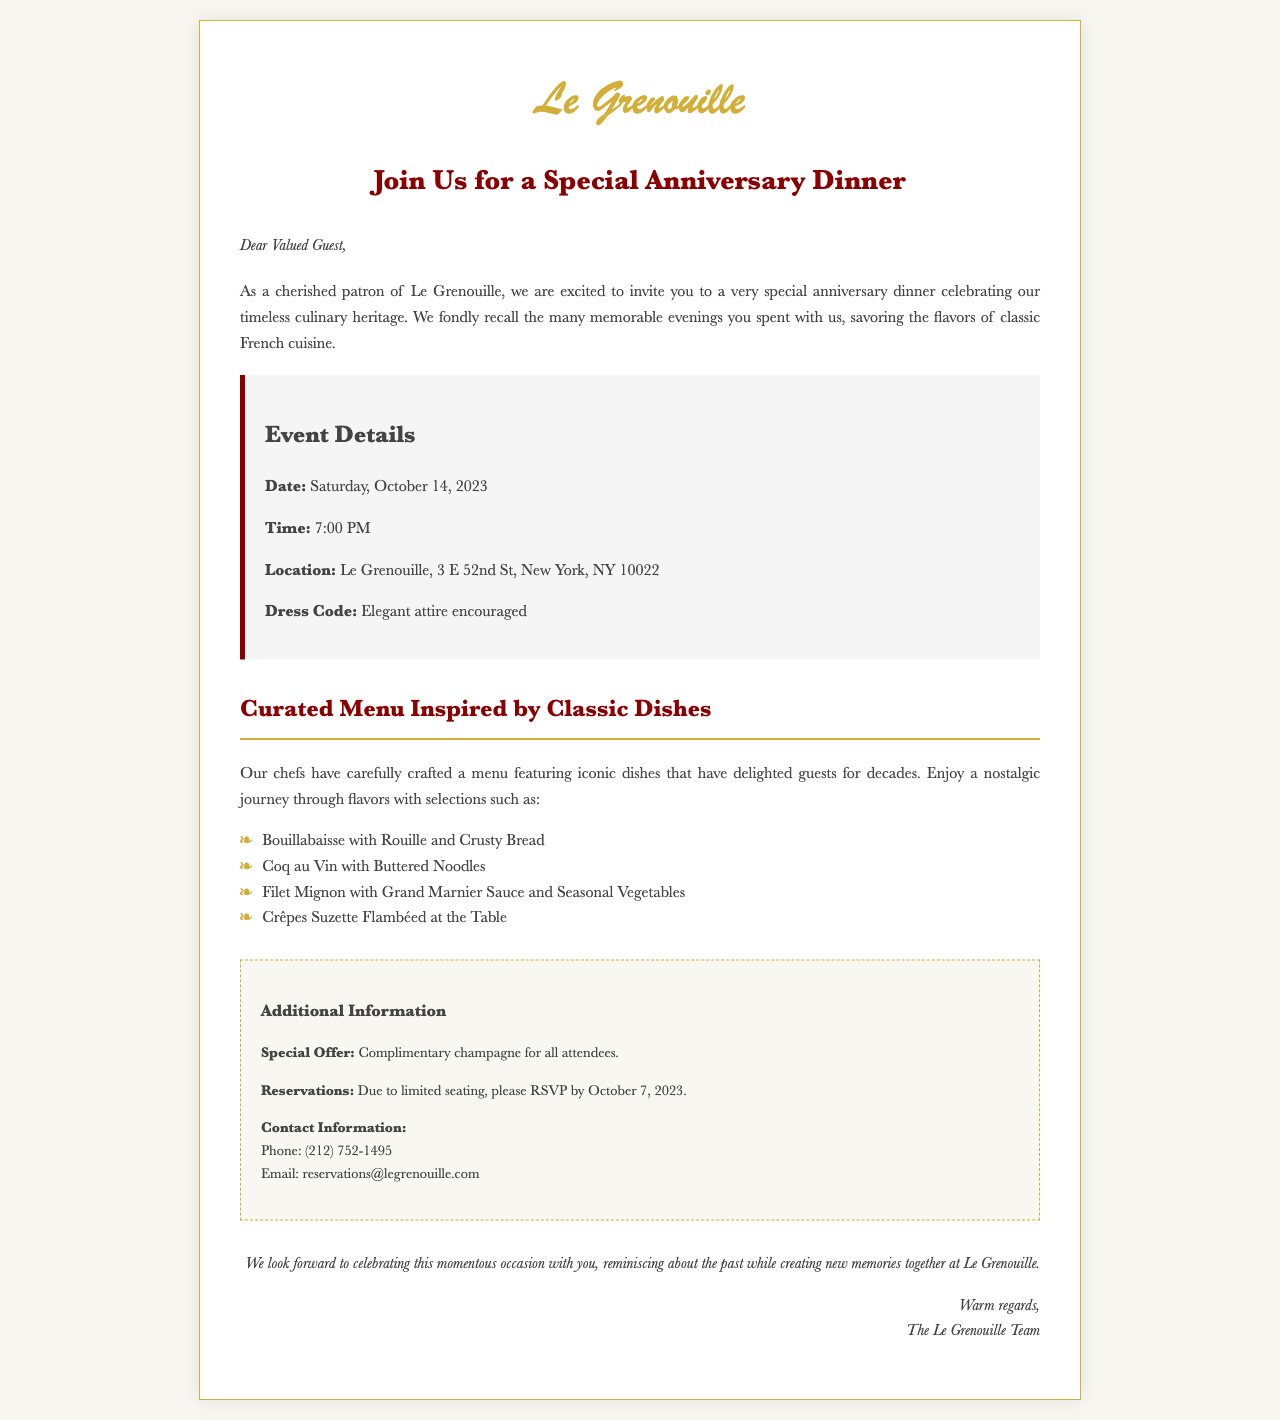what is the date of the event? The date of the anniversary dinner is stated in the event details section of the document.
Answer: Saturday, October 14, 2023 what time does the dinner start? The start time for the dinner is mentioned in the event details section.
Answer: 7:00 PM where is Le Grenouille located? The location of Le Grenouille is provided in the event details.
Answer: 3 E 52nd St, New York, NY 10022 what is the dress code for the event? The dress code is described in the event details of the invitation.
Answer: Elegant attire encouraged what is offered to all attendees? A special offer for the guests is highlighted in the additional information section.
Answer: Complimentary champagne when is the RSVP deadline? The deadline for RSVPs is mentioned in the additional information section.
Answer: October 7, 2023 what type of cuisine is featured in the menu? The cuisine type is indicated in the introduction to the menu section.
Answer: Classic French cuisine which dish is prepared with seasonal vegetables? A specific dish alongside seasonal vegetables is listed in the curated menu section.
Answer: Filet Mignon with Grand Marnier Sauce and Seasonal Vegetables what should guests look forward to during the event? The closing statement suggests what the guests can expect from the event.
Answer: Celebrating this momentous occasion 